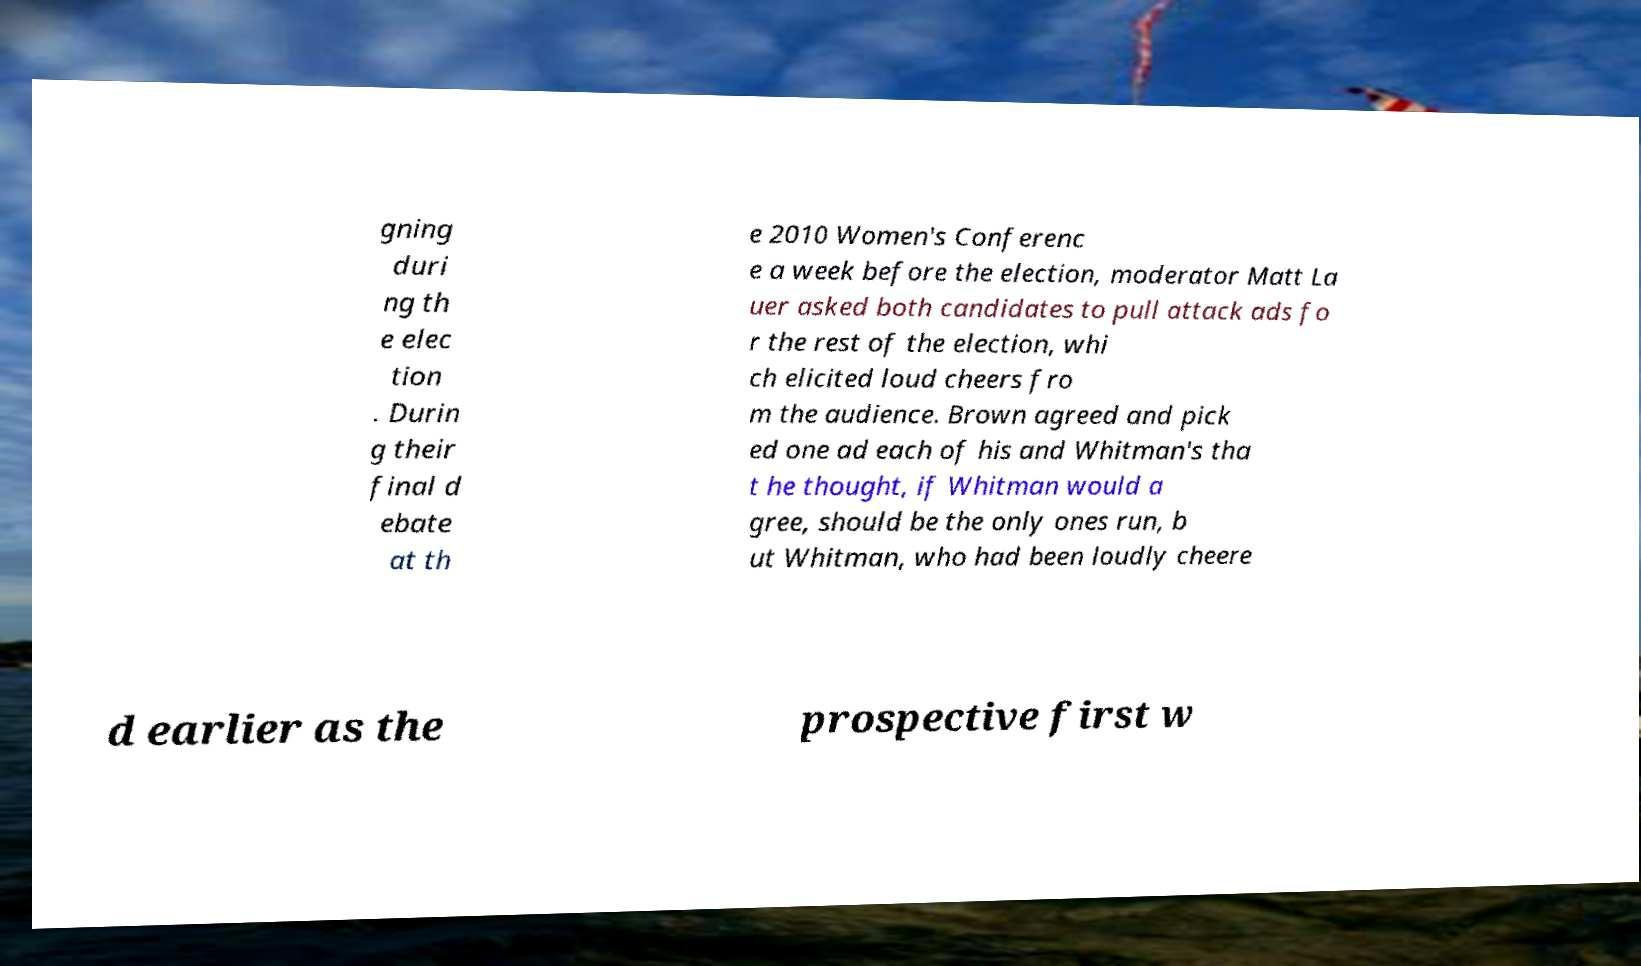I need the written content from this picture converted into text. Can you do that? gning duri ng th e elec tion . Durin g their final d ebate at th e 2010 Women's Conferenc e a week before the election, moderator Matt La uer asked both candidates to pull attack ads fo r the rest of the election, whi ch elicited loud cheers fro m the audience. Brown agreed and pick ed one ad each of his and Whitman's tha t he thought, if Whitman would a gree, should be the only ones run, b ut Whitman, who had been loudly cheere d earlier as the prospective first w 